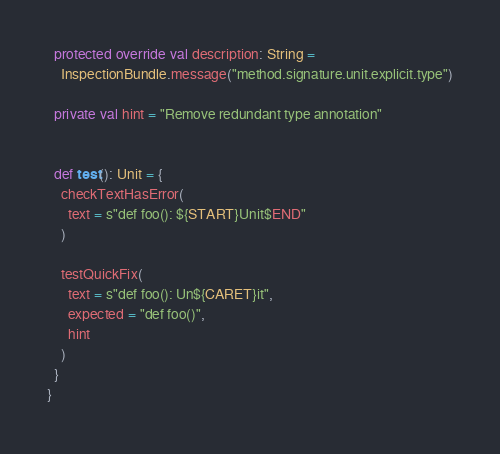<code> <loc_0><loc_0><loc_500><loc_500><_Scala_>
  protected override val description: String =
    InspectionBundle.message("method.signature.unit.explicit.type")

  private val hint = "Remove redundant type annotation"


  def test(): Unit = {
    checkTextHasError(
      text = s"def foo(): ${START}Unit$END"
    )

    testQuickFix(
      text = s"def foo(): Un${CARET}it",
      expected = "def foo()",
      hint
    )
  }
}
</code> 